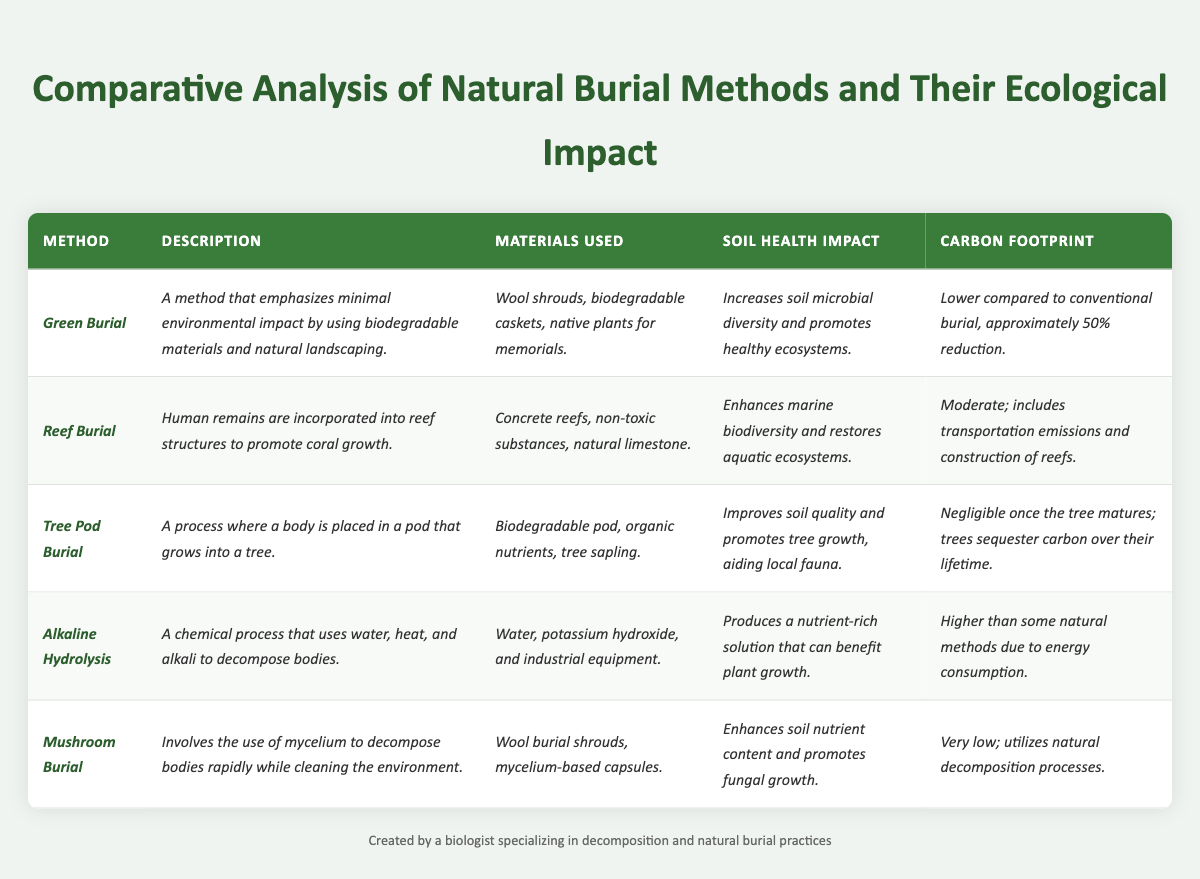What is the carbon footprint impact of Green Burial? The table states that the carbon footprint of Green Burial is lower compared to conventional burial, specifically indicating an approximate 50% reduction.
Answer: 50% reduction Which burial method has the highest carbon footprint? The table doesn't provide specific numbers but implies that Alkaline Hydrolysis has the highest carbon footprint due to energy consumption compared to other methods listed.
Answer: Alkaline Hydrolysis Does Tree Pod Burial improve soil quality? The description for Tree Pod Burial states that it improves soil quality and promotes tree growth, confirming the impact on soil health.
Answer: Yes What materials are used in Mushroom Burial? The table lists the materials used in Mushroom Burial as wool burial shrouds and mycelium-based capsules.
Answer: Wool burial shrouds and mycelium-based capsules How does Reef Burial impact marine ecosystems? The table states that Reef Burial enhances marine biodiversity and restores aquatic ecosystems, indicating a positive ecological impact.
Answer: Enhances marine biodiversity Which method uses concrete for its process? Reef Burial is the method that specifies the use of concrete reefs in its materials.
Answer: Reef Burial Compare the soil health impact of Green Burial and Alkaline Hydrolysis. Green Burial increases soil microbial diversity and promotes healthy ecosystems, whereas Alkaline Hydrolysis produces a nutrient-rich solution that can benefit plant growth, showing both have positive, but different impacts.
Answer: Both have positive impacts What is the combined carbon footprint impact of Tree Pod Burial and Mushroom Burial once fully developed? Tree Pod Burial has a negligible carbon footprint once the tree matures and Mushroom Burial has a very low footprint due to natural processes. The combined impact remains very low.
Answer: Very low Which burial method emphasizes minimal environmental impact and uses biodegradable materials? The entry for Green Burial specifies that it emphasizes minimal environmental impact by using biodegradable materials.
Answer: Green Burial How do the carbon footprints of the burial methods relate to each other? Comparing carbon footprints: Green Burial has a 50% reduction, Reef Burial is moderate, Tree Pod Burial is negligible post-maturity, Alkaline Hydrolysis is higher due to energy use, and Mushroom Burial is very low. Alkaline Hydrolysis has the highest, while Tree Pod and Mushroom Burials have the least impact.
Answer: Alkaline Hydrolysis is highest; Tree Pod and Mushroom are lowest 